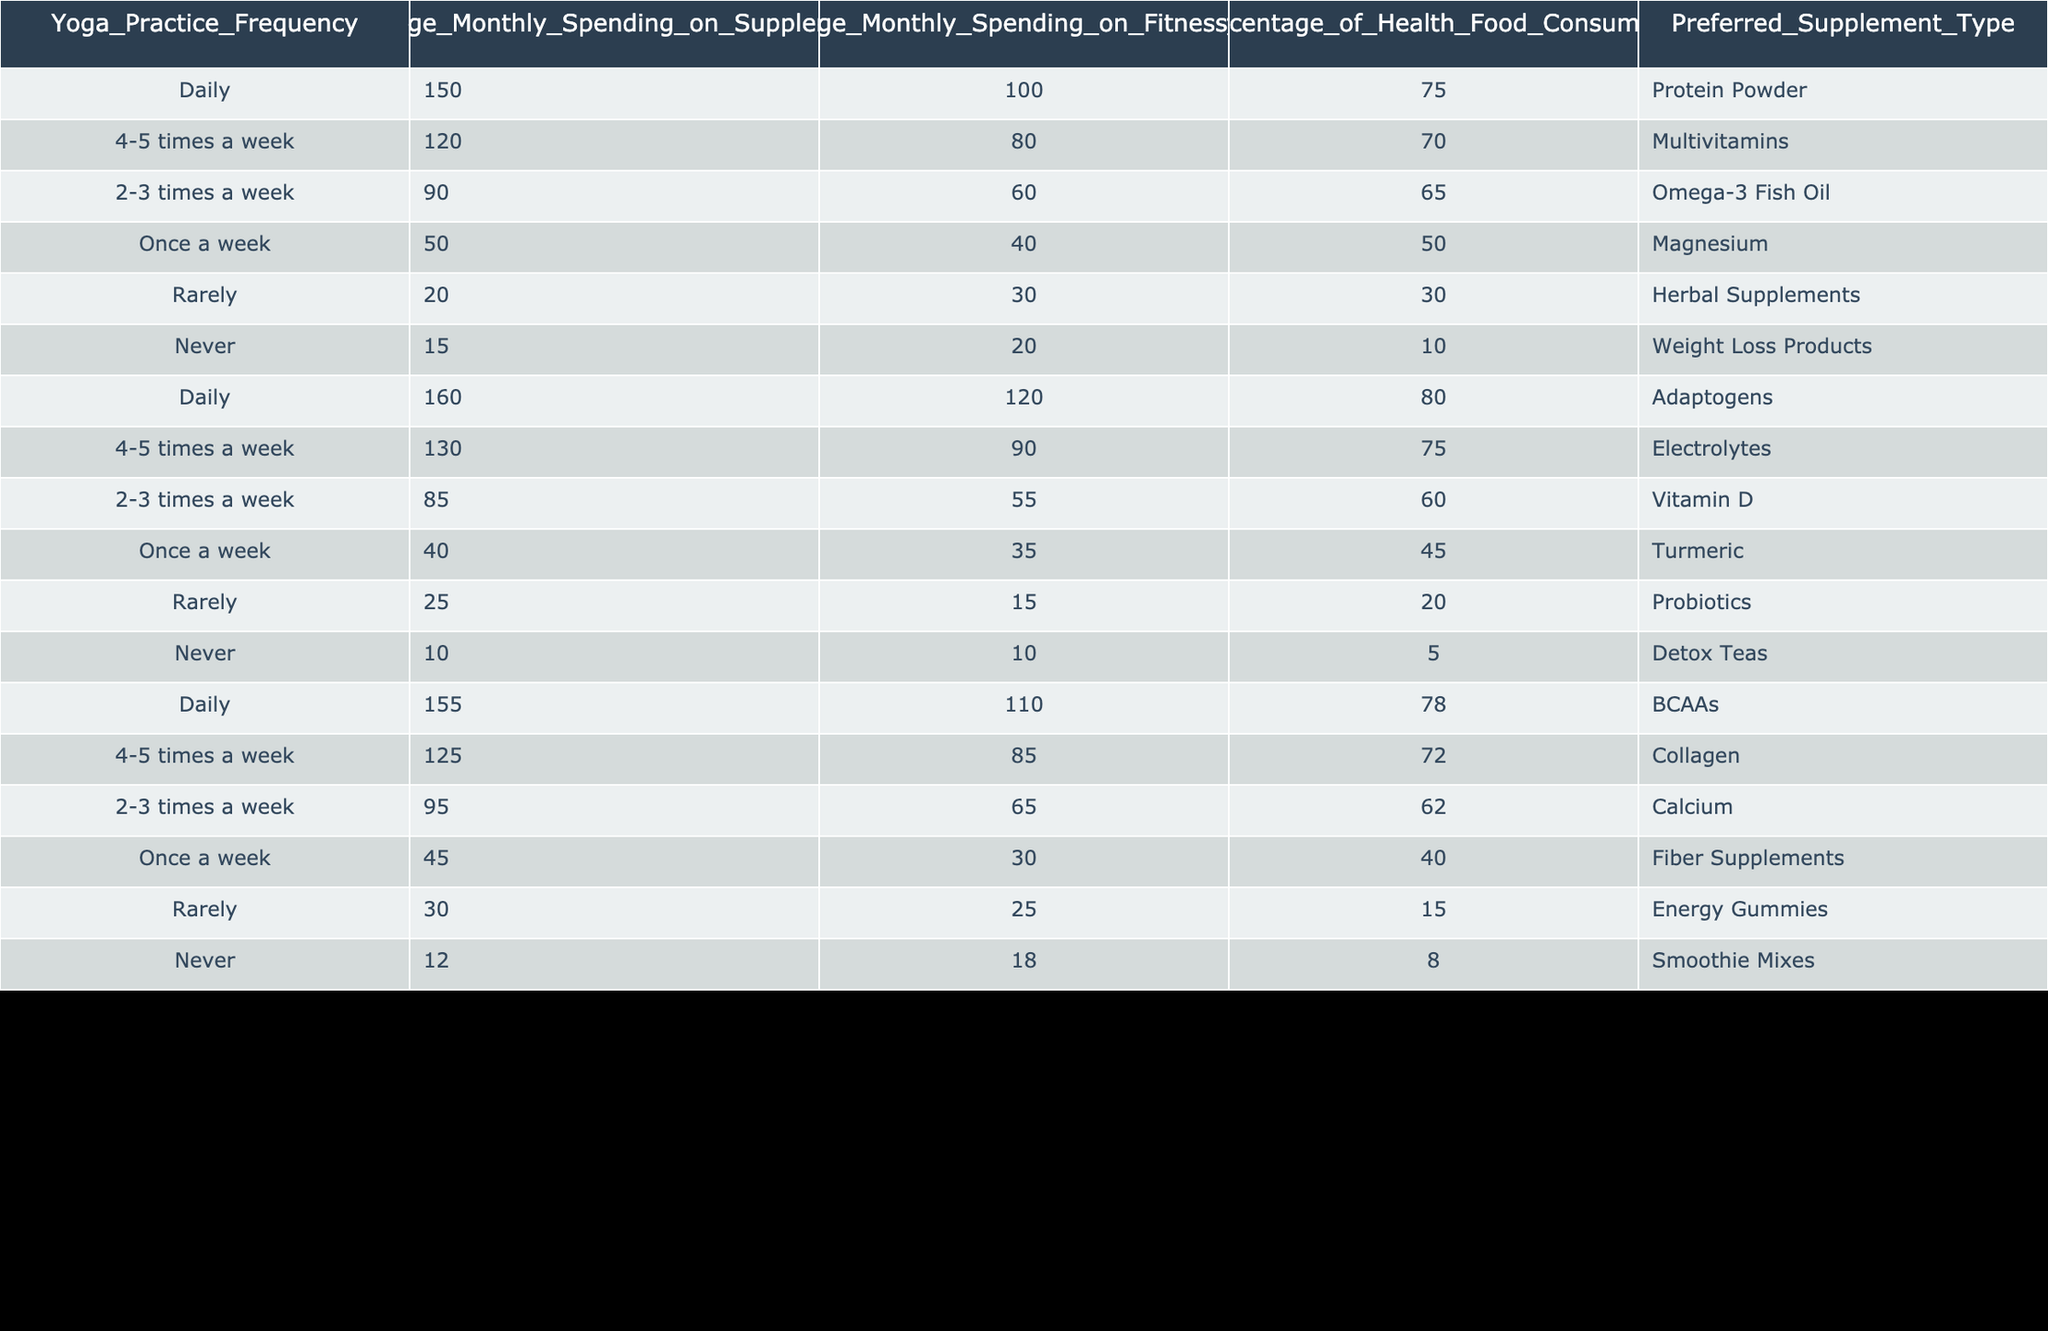What is the average monthly spending on supplements for individuals who practice yoga daily? Looking at the row corresponding to "Daily" yoga practice frequency, the average monthly spending on supplements listed is 150.
Answer: 150 Which preferred supplement type is most commonly associated with practicing yoga daily? In the row for "Daily," the preferred supplement type is noted as "Protein Powder," making it the most common.
Answer: Protein Powder What is the total average monthly spending on fitness gear for those who practice yoga 4-5 times a week? For "4-5 times a week," the average spending on fitness gear is 80. There is only one row to consider here, so the total is simply 80.
Answer: 80 Is the percentage of health food consumers higher for those who practice yoga 2-3 times a week compared to those who practice it once a week? For "2-3 times a week," the percentage is 65, while for "Once a week," it is 50. Since 65 is greater than 50, the answer is yes.
Answer: Yes What is the difference in average monthly spending on supplements between those who practice yoga daily and those who practice it rarely? The spending for "Daily" is 150 and for "Rarely" is 20. The difference is calculated as 150 - 20 = 130.
Answer: 130 How many individuals practicing yoga daily spend more than 100 on fitness gear? From the "Daily" rows, there are two entries: one spending 100 and the other 120. Only the entry with 120 spends more than 100. Thus, the count is 1.
Answer: 1 What is the average percentage of health food consumers among those who never practice yoga? For "Never," there are two entries with percentages of 10 and 5. The average is calculated as (10 + 5) / 2 = 7.5.
Answer: 7.5 Which group spends the least on fitness gear, and how much do they spend? The row with "Never" records the spending on fitness gear as 20, the lowest compared to all other entries.
Answer: 20 Is the preferred supplement type for individuals who practice yoga once a week more focused on minerals or vitamins? The preferred supplement type for "Once a week" is "Magnesium," which is a mineral, thus indicating a focus on minerals.
Answer: Yes What is the average spending on supplements for those who practice yoga 4-5 times a week and those who practice it 2-3 times a week? For "4-5 times a week," the spending is 120, and for "2-3 times a week," it is 90. The average is calculated as (120 + 90) / 2 = 105.
Answer: 105 